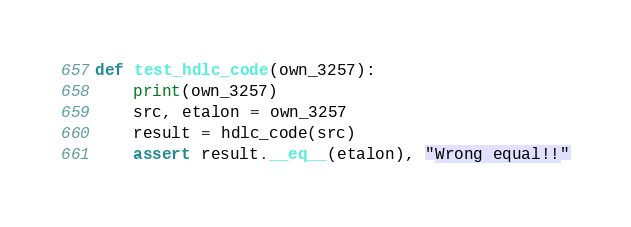<code> <loc_0><loc_0><loc_500><loc_500><_Python_>

def test_hdlc_code(own_3257):
    print(own_3257)
    src, etalon = own_3257
    result = hdlc_code(src)
    assert result.__eq__(etalon), "Wrong equal!!"











</code> 